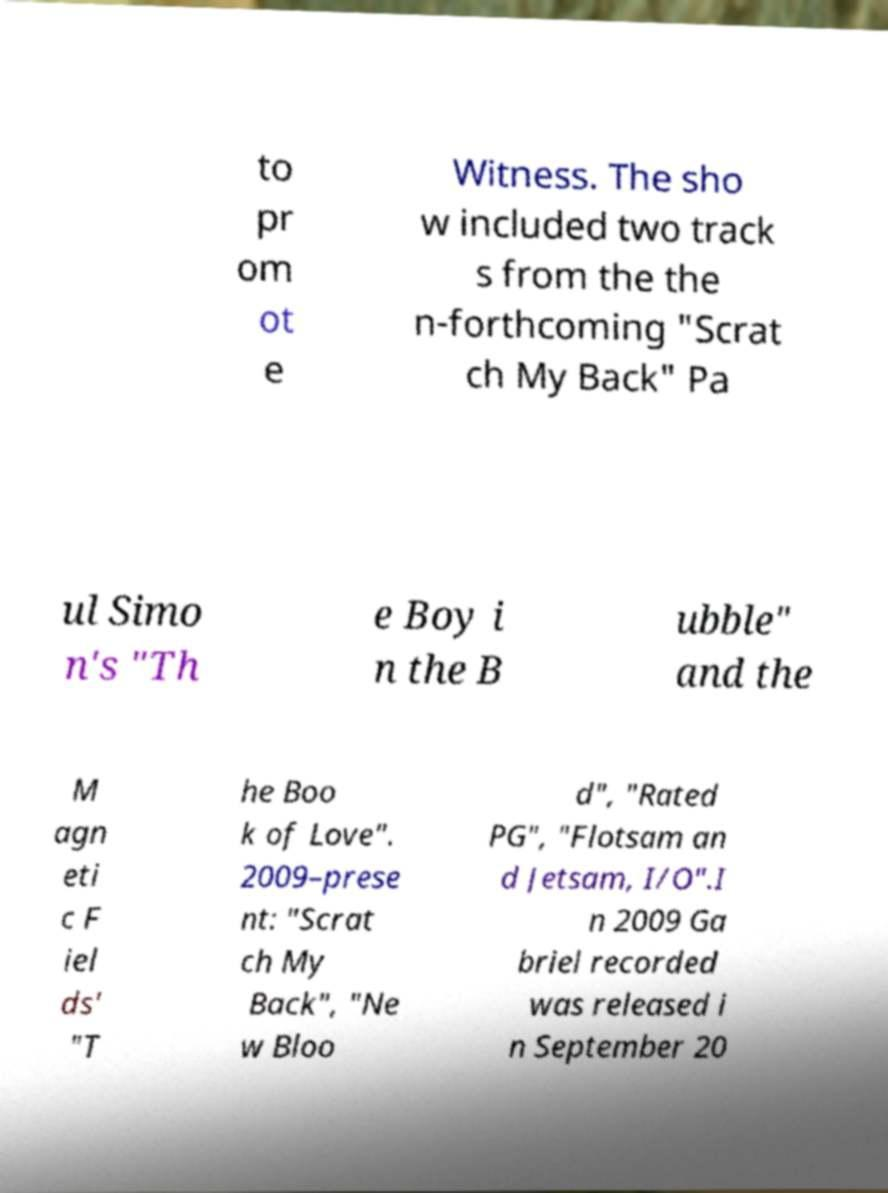There's text embedded in this image that I need extracted. Can you transcribe it verbatim? to pr om ot e Witness. The sho w included two track s from the the n-forthcoming "Scrat ch My Back" Pa ul Simo n's "Th e Boy i n the B ubble" and the M agn eti c F iel ds' "T he Boo k of Love". 2009–prese nt: "Scrat ch My Back", "Ne w Bloo d", "Rated PG", "Flotsam an d Jetsam, I/O".I n 2009 Ga briel recorded was released i n September 20 